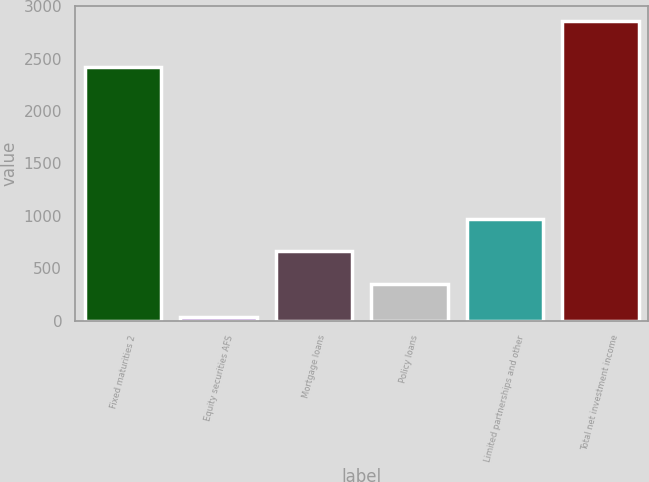Convert chart. <chart><loc_0><loc_0><loc_500><loc_500><bar_chart><fcel>Fixed maturities 2<fcel>Equity securities AFS<fcel>Mortgage loans<fcel>Policy loans<fcel>Limited partnerships and other<fcel>Total net investment income<nl><fcel>2420<fcel>38<fcel>661.2<fcel>349.6<fcel>972.8<fcel>2860<nl></chart> 